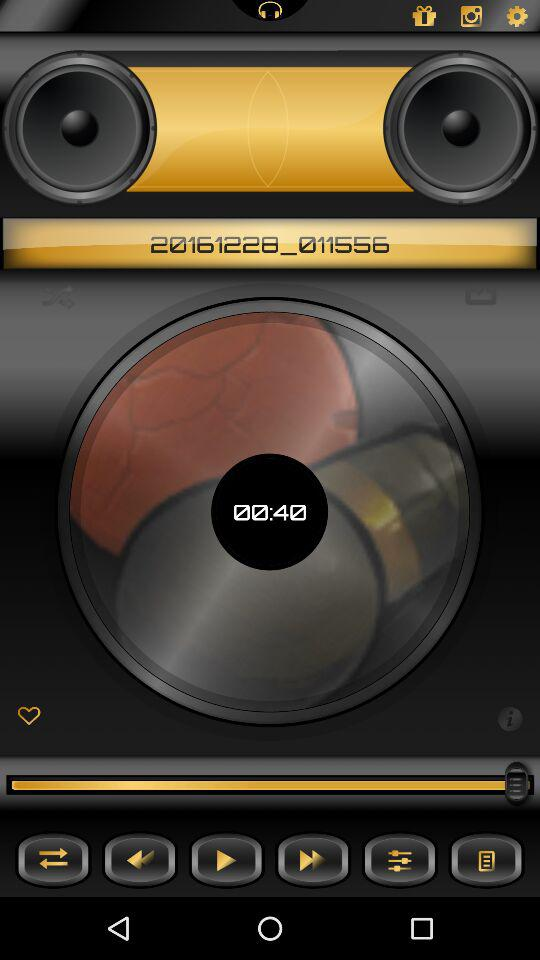How many speakers are displayed on the screen?
Answer the question using a single word or phrase. 2 